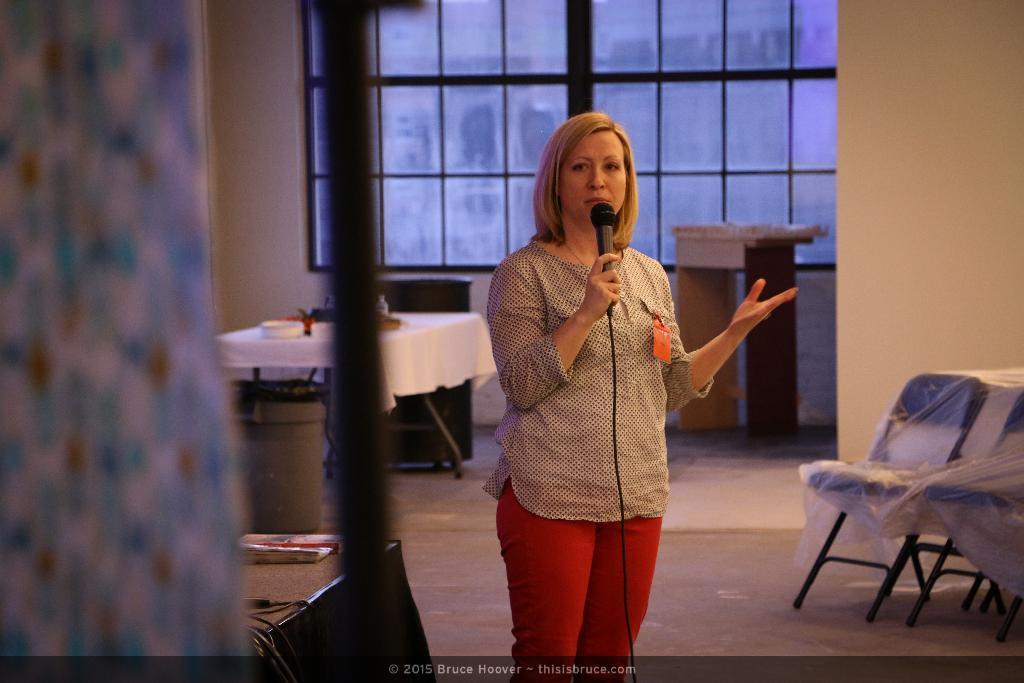Can you describe this image briefly? There is a lady holding a mic and wearing a badge. On the right side there are chairs. In the back there is table. On the table there are some items. Near to the table there is a box and a bin. Also there is a podium and glass wall. On the left side there is a pole and a stand. On the stand there is a book. At the bottom there is a watermark. 